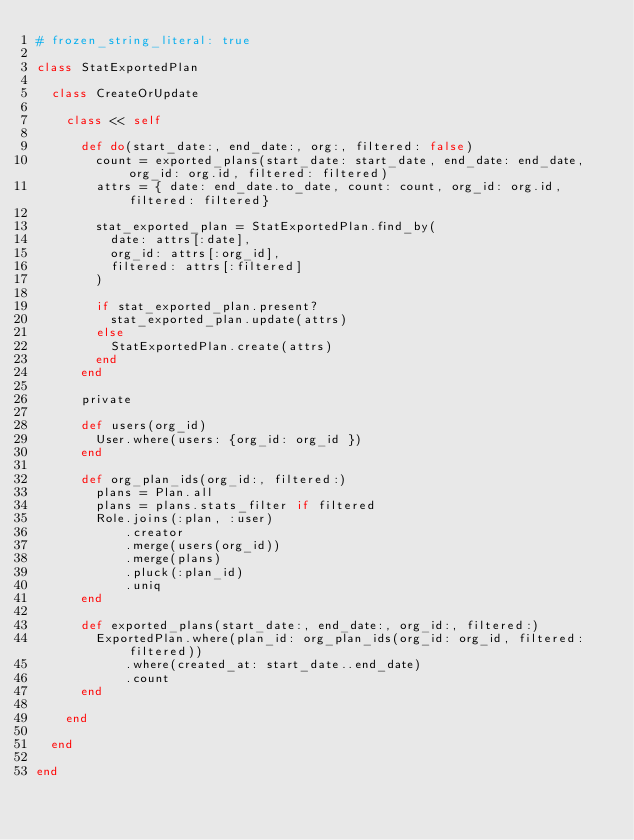<code> <loc_0><loc_0><loc_500><loc_500><_Ruby_># frozen_string_literal: true

class StatExportedPlan

  class CreateOrUpdate

    class << self

      def do(start_date:, end_date:, org:, filtered: false)
        count = exported_plans(start_date: start_date, end_date: end_date, org_id: org.id, filtered: filtered)
        attrs = { date: end_date.to_date, count: count, org_id: org.id, filtered: filtered}

        stat_exported_plan = StatExportedPlan.find_by(
          date: attrs[:date],
          org_id: attrs[:org_id],
          filtered: attrs[:filtered]
        )

        if stat_exported_plan.present?
          stat_exported_plan.update(attrs)
        else
          StatExportedPlan.create(attrs)
        end
      end

      private

      def users(org_id)
        User.where(users: {org_id: org_id })
      end

      def org_plan_ids(org_id:, filtered:)
        plans = Plan.all
        plans = plans.stats_filter if filtered
        Role.joins(:plan, :user)
            .creator
            .merge(users(org_id))
            .merge(plans)
            .pluck(:plan_id)
            .uniq
      end

      def exported_plans(start_date:, end_date:, org_id:, filtered:)
        ExportedPlan.where(plan_id: org_plan_ids(org_id: org_id, filtered: filtered))
            .where(created_at: start_date..end_date)
            .count
      end

    end

  end

end
</code> 